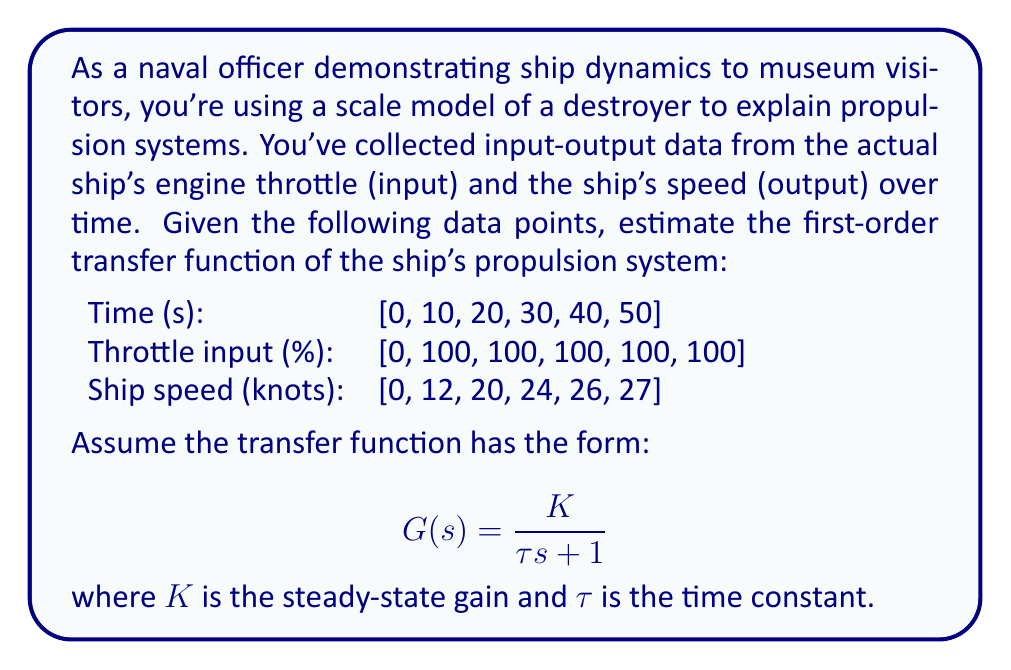Can you answer this question? To estimate the first-order transfer function, we need to determine the steady-state gain $K$ and the time constant $\tau$. Let's approach this step-by-step:

1. Steady-state gain $(K)$:
   The steady-state gain is the ratio of the output change to the input change at steady state.
   $$ K = \frac{\text{Output change}}{\text{Input change}} = \frac{27 - 0}{100 - 0} = 0.27 \frac{\text{knots}}{\%} $$

2. Time constant $(\tau)$:
   The time constant is the time it takes for the system to reach 63.2% of its final value.
   Final value = 27 knots
   63.2% of final value = $27 * 0.632 = 17.064$ knots

   Interpolating between the given data points:
   At 20 seconds: 20 knots
   At 30 seconds: 24 knots
   
   The system reaches 17.064 knots between 10 and 20 seconds. Using linear interpolation:
   $$ \tau = 10 + \frac{17.064 - 12}{20 - 12} * 10 \approx 16.33 \text{ seconds} $$

3. Transfer function:
   Substituting the values into the given form:
   $$ G(s) = \frac{0.27}{16.33s + 1} $$

This transfer function represents a simplified model of the ship's propulsion system, relating the throttle input to the ship's speed output.
Answer: $$ G(s) = \frac{0.27}{16.33s + 1} $$ 